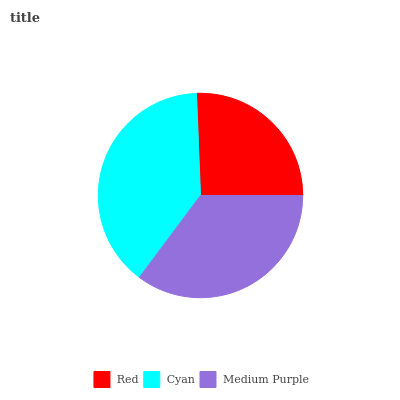Is Red the minimum?
Answer yes or no. Yes. Is Cyan the maximum?
Answer yes or no. Yes. Is Medium Purple the minimum?
Answer yes or no. No. Is Medium Purple the maximum?
Answer yes or no. No. Is Cyan greater than Medium Purple?
Answer yes or no. Yes. Is Medium Purple less than Cyan?
Answer yes or no. Yes. Is Medium Purple greater than Cyan?
Answer yes or no. No. Is Cyan less than Medium Purple?
Answer yes or no. No. Is Medium Purple the high median?
Answer yes or no. Yes. Is Medium Purple the low median?
Answer yes or no. Yes. Is Cyan the high median?
Answer yes or no. No. Is Red the low median?
Answer yes or no. No. 